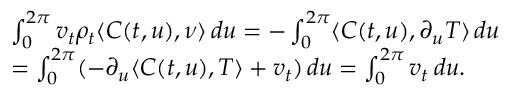Convert formula to latex. <formula><loc_0><loc_0><loc_500><loc_500>\begin{array} { r l } & { \int _ { 0 } ^ { 2 \pi } v _ { t } \rho _ { t } \langle C ( t , u ) , \nu \rangle \, d u = - \int _ { 0 } ^ { 2 \pi } \langle C ( t , u ) , \partial _ { u } T \rangle \, d u } \\ & { = \int _ { 0 } ^ { 2 \pi } ( - \partial _ { u } \langle C ( t , u ) , T \rangle + v _ { t } ) \, d u = \int _ { 0 } ^ { 2 \pi } v _ { t } \, d u . } \end{array}</formula> 